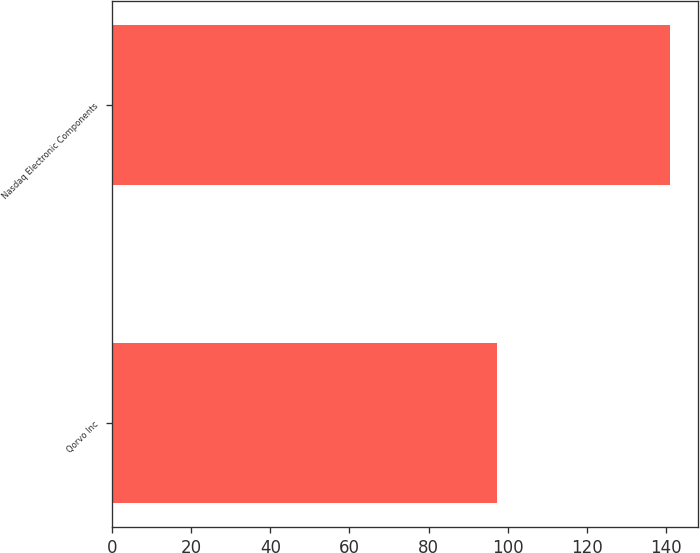Convert chart. <chart><loc_0><loc_0><loc_500><loc_500><bar_chart><fcel>Qorvo Inc<fcel>Nasdaq Electronic Components<nl><fcel>97.39<fcel>141.13<nl></chart> 